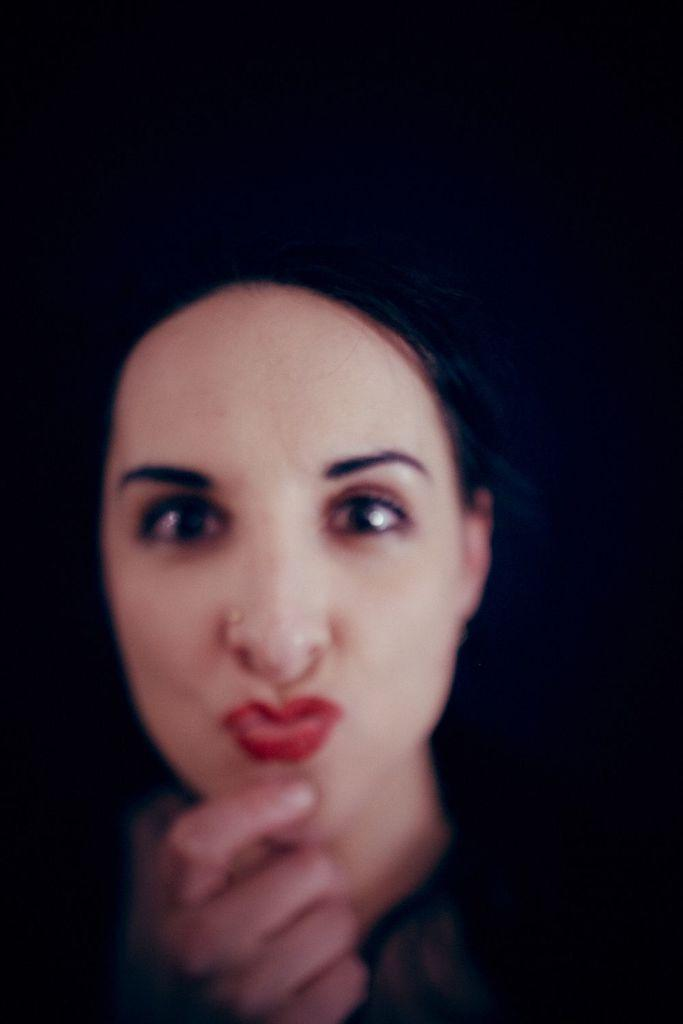Who is the main subject in the image? There is a woman in the image. What can be observed about the background of the image? The background of the image is dark. What is there is a chance for the woman to run in the image? There is no indication of the woman running or any chance of her running in the image, as it only shows her and a dark background. 